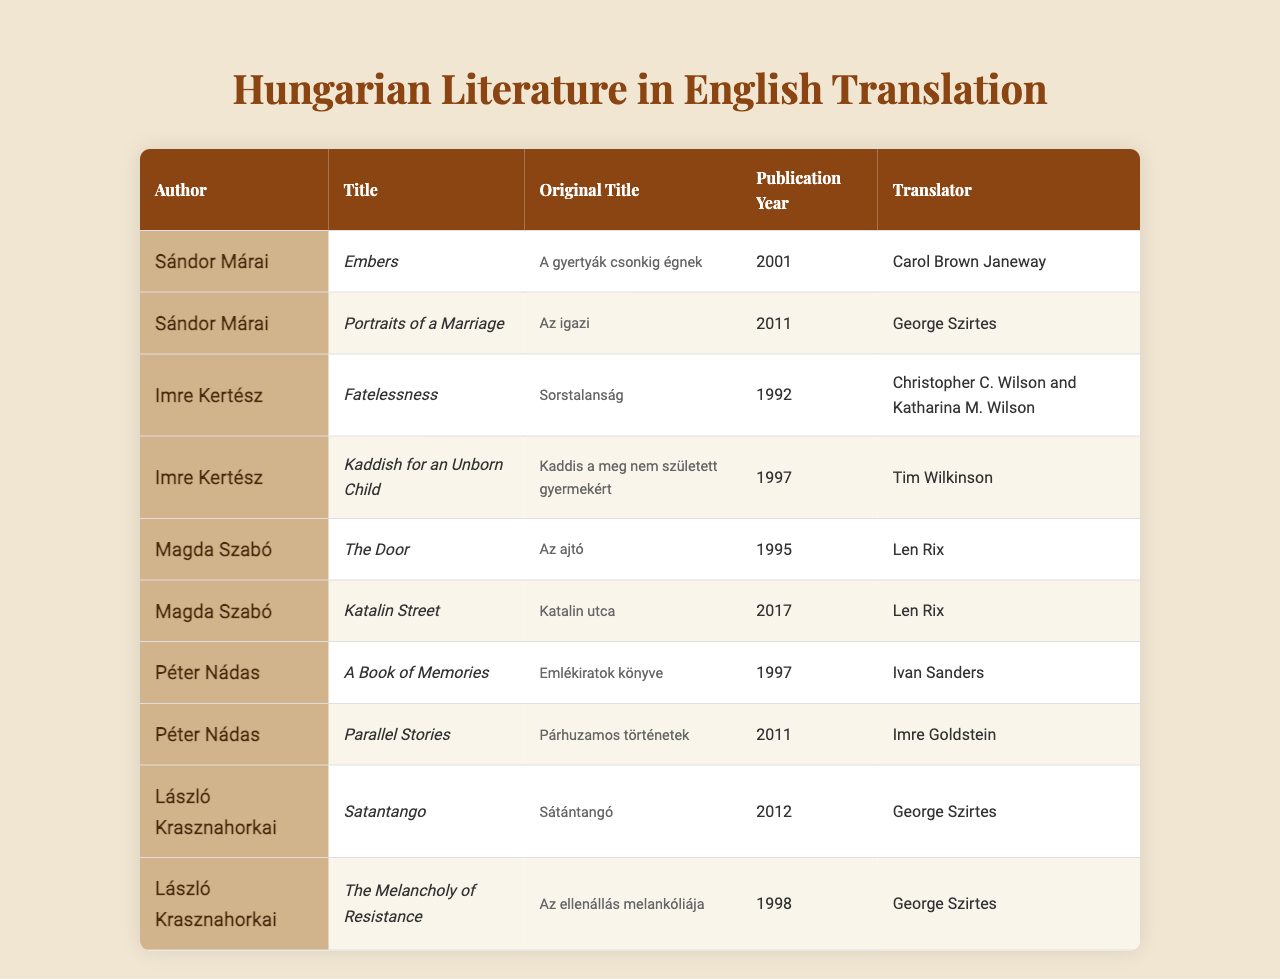What is the title of Sándor Márai's work published in 2001? According to the table under Sándor Márai, the work listed for the publication year 2001 is "Embers."
Answer: Embers Who translated "Kaddish for an Unborn Child"? Looking at the entry for "Kaddish for an Unborn Child," the translator mentioned next to it is Tim Wilkinson.
Answer: Tim Wilkinson Which author has the most works listed in the table? The table shows that the authors Sándor Márai, Imre Kertész, Magda Szabó, Péter Nádas, and László Krasznahorkai each have two works listed, so they all have the same number.
Answer: Equal number, 2 works each In what year was "The Door" published? Referring to the table, "The Door" is listed with the publication year 1995.
Answer: 1995 Are there more works translated by George Szirtes or by Len Rix? The table indicates that George Szirtes translated two works, while Len Rix also translated two works, so they are equal.
Answer: Equal, 2 works each What is the original title of "Fatelessness"? Looking at the row for "Fatelessness," the original title is "Sorstalanság."
Answer: Sorstalanság Which author’s works were published most recently, and what are their titles? Checking the publication years, Magda Szabó's "Katalin Street" in 2017 is the most recent work, so she is the author with the most recent publication along with its title.
Answer: Magda Szabó, "Katalin Street" What is the average publication year of the books listed in the table? To find the average, we add the publication years: (2001 + 2011 + 1992 + 1997 + 1995 + 2017 + 1997 + 2011 + 2012 + 1998) / 10 = 2001. The sum is 2001, and dividing it by 10 gives us 200.1.
Answer: 2001 How many translators are listed for works in the table? The table lists unique translators: Carol Brown Janeway, George Szirtes, Christopher C. Wilson and Katharina M. Wilson, Tim Wilkinson, Len Rix, Ivan Sanders, and Imre Goldstein, making a total of seven unique translators.
Answer: 7 Which work was translated by George Szirtes and published in 2012? According to the table, the work translated by George Szirtes published in 2012 is "Satantango."
Answer: Satantango 